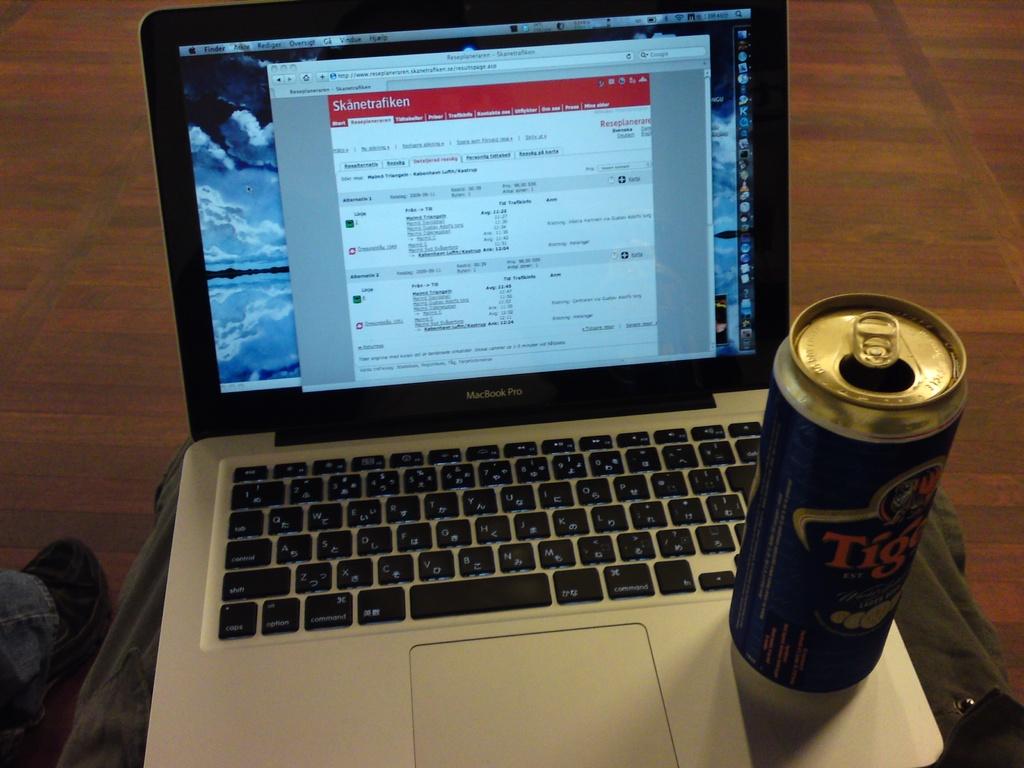What kind of laptop is that?
Provide a short and direct response. Macbook pro. What brand is the drink?
Provide a succinct answer. Tiger. 